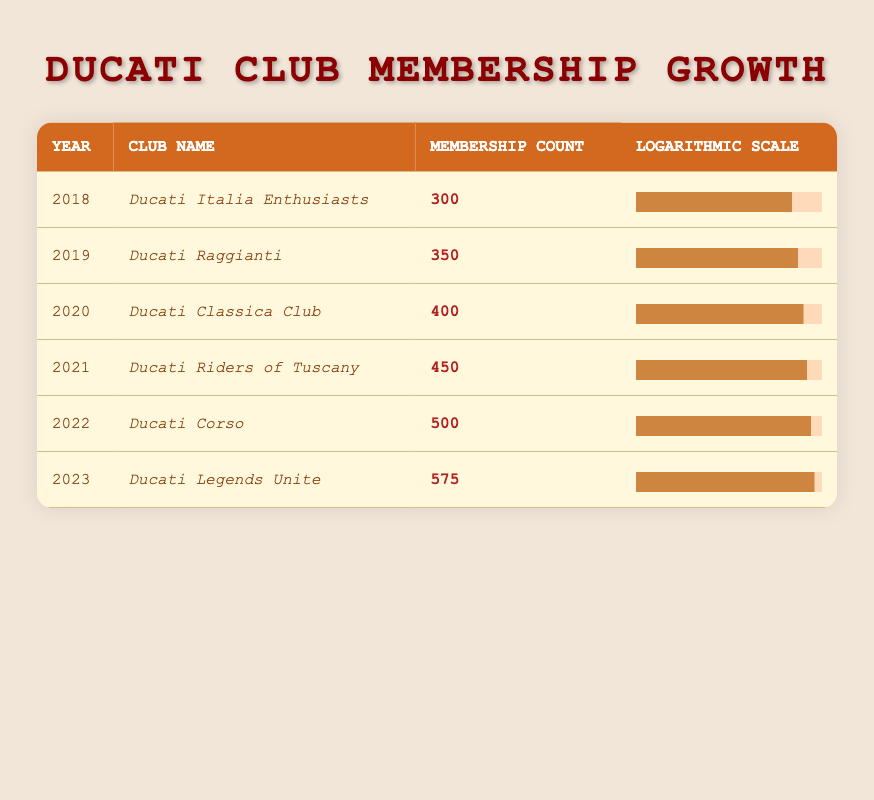What was the membership count for Ducati Corso in 2022? The table directly lists the membership count for each club in the corresponding year. For 2022, under the club name Ducati Corso, the membership count is shown as 500.
Answer: 500 Which club had the highest membership count and what was that count? By examining the table for the highest value in the Membership Count column, it is evident that Ducati Legends Unite had the highest membership count at 575 in 2023.
Answer: Ducati Legends Unite, 575 What was the total membership count from 2018 to 2023? To find the total membership count from the years listed, we add each year's membership count: 300 + 350 + 400 + 450 + 500 + 575 = 2575.
Answer: 2575 Is the membership of Ducati Riders of Tuscany greater than the average membership from 2019 to 2023? First, we calculate the average membership for the years 2019 to 2023. The membership counts are: 350 (2019), 400 (2020), 450 (2021), 500 (2022), and 575 (2023). Their total is 2275, and the average is 2275/5 = 455. Since Ducati Riders of Tuscany has 450 members, which is not greater than 455, the answer is no.
Answer: No What is the increase in membership from 2018 to 2023? To find the increase, we subtract the membership count for 2018 from that of 2023: 575 (2023) - 300 (2018) = 275.
Answer: 275 Was there an increase in membership every year from 2018 to 2023? We need to check the membership counts year by year: 300 (2018) to 350 (2019) is an increase; 350 to 400 (2020) is an increase; 400 to 450 (2021) is an increase; 450 to 500 (2022) is an increase; and 500 to 575 (2023) is also an increase. Since all values show an increase, the answer is yes.
Answer: Yes What is the percentage increase in membership from 2022 to 2023? To calculate the percentage increase from 2022 to 2023, we find the difference in membership counts (575 - 500 = 75), then divide this by the 2022 membership count (500), and multiply by 100 to convert it to a percentage. Therefore, (75/500) * 100 = 15%.
Answer: 15% Calculate the average membership count for the clubs over the years listed in the table. To find the average, we need to sum the membership counts: 300 + 350 + 400 + 450 + 500 + 575 = 2575. Dividing this sum by the count of years (6), we find 2575/6 = approximately 429.17.
Answer: 429.17 